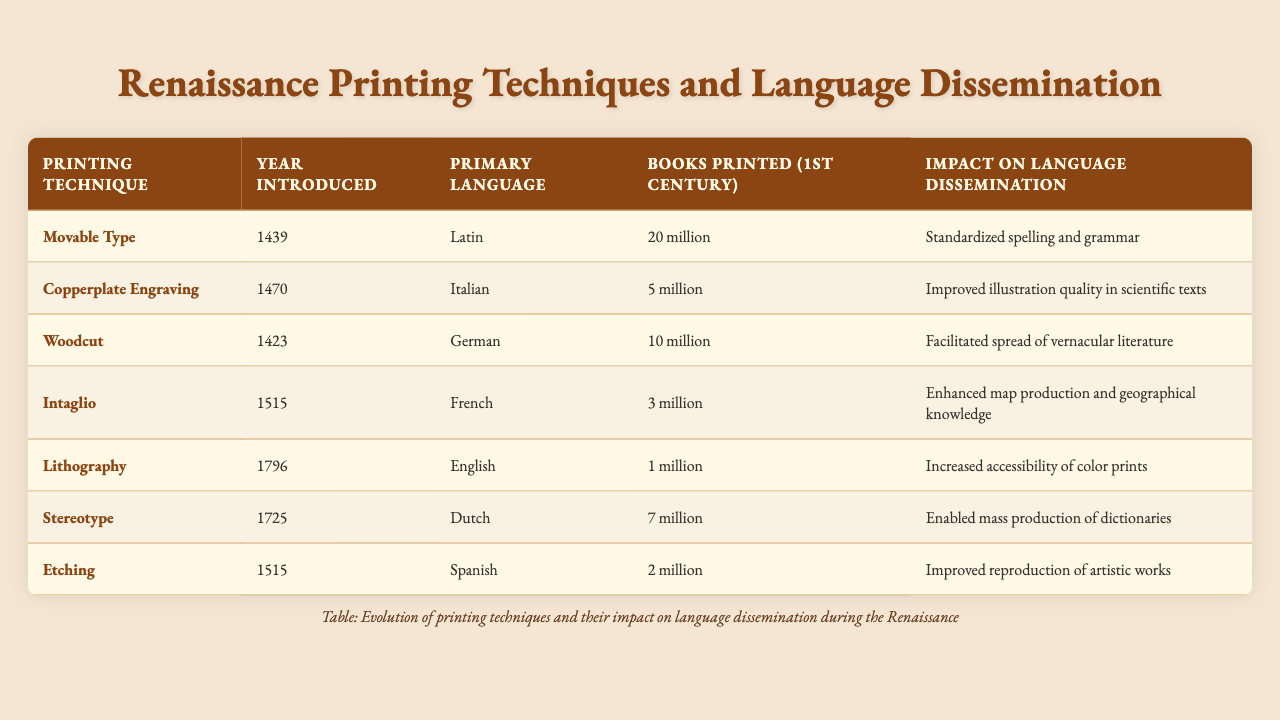What printing technique was introduced in 1439? Referring to the table, the technique listed for the year 1439 is "Movable Type."
Answer: Movable Type Which language was primarily associated with "Woodcut"? Looking at the table, "Woodcut" is associated with the "German" language.
Answer: German How many books were printed using "Copperplate Engraving"? The table indicates that 5 million books were printed using the "Copperplate Engraving" technique.
Answer: 5 million What was the impact of the "Lithography" printing technique? According to the table, the impact of "Lithography" was to increase the accessibility of color prints.
Answer: Increased accessibility of color prints Which printing technique had the highest number of books printed in the first century? The table shows that "Movable Type" had the highest number of books printed with 20 million.
Answer: Movable Type What is the difference in the number of books printed between "Movable Type" and "Woodcut"? From the table, "Movable Type" had 20 million books printed and "Woodcut" had 10 million. The difference is 20 million - 10 million = 10 million.
Answer: 10 million Was "Intaglio" primarily associated with Italian? Checking the table, "Intaglio" is associated with the "French" language, so that statement is false.
Answer: No Which printing technique was introduced first, "Etching" or "Intaglio"? The table shows "Etching" was introduced in 1515, the same year as "Intaglio," but since both were introduced in 1515, they were introduced simultaneously.
Answer: They were introduced simultaneously Which language had the lowest number of books printed in the first century? Referring to the table, "Lithography" associated with the English language had the lowest number of books printed at 1 million.
Answer: English What was the collective impact of both "Stereotype" and "Movable Type"? The impact of "Stereotype" was to enable mass production of dictionaries, while "Movable Type" standardized spelling and grammar. Collectively, they enhanced the standardization and accessibility of language through mass production and dictionary availability.
Answer: Enhanced language standardization and accessibility 